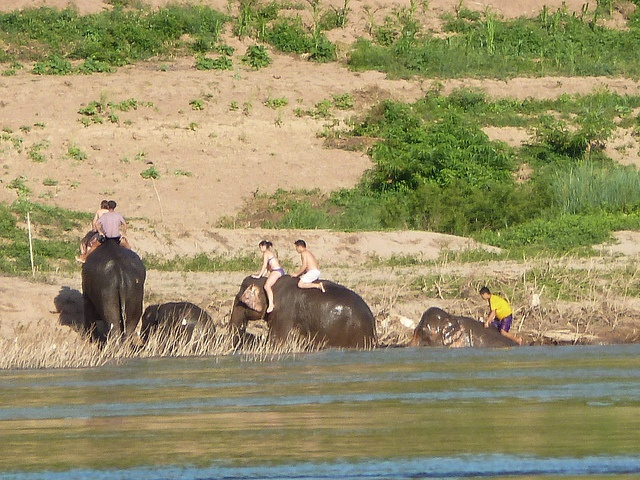Describe the objects in this image and their specific colors. I can see elephant in tan, gray, and maroon tones, elephant in tan, black, and gray tones, elephant in tan, gray, and maroon tones, people in tan, pink, gray, and black tones, and elephant in tan, black, gray, and maroon tones in this image. 